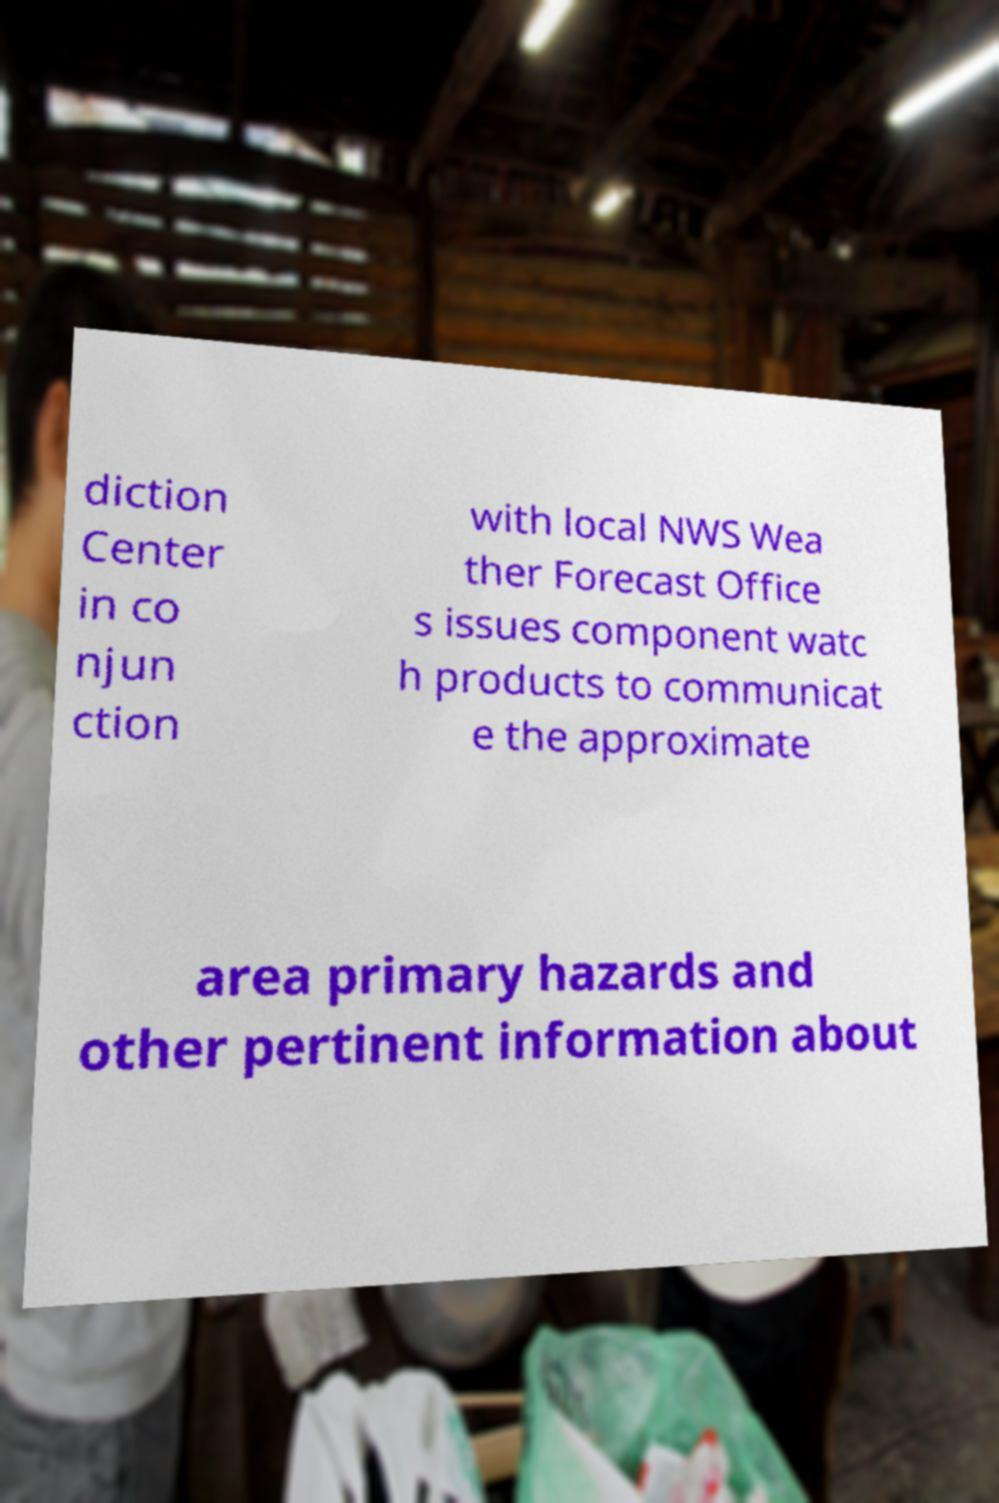Can you read and provide the text displayed in the image?This photo seems to have some interesting text. Can you extract and type it out for me? diction Center in co njun ction with local NWS Wea ther Forecast Office s issues component watc h products to communicat e the approximate area primary hazards and other pertinent information about 